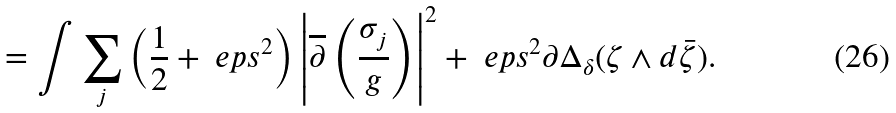<formula> <loc_0><loc_0><loc_500><loc_500>= \int \sum _ { j } \left ( \frac { 1 } { 2 } + { \ e p s } ^ { 2 } \right ) \left | \overline { \partial } \left ( \frac { \sigma _ { j } } { g } \right ) \right | ^ { 2 } + { \ e p s } ^ { 2 } \partial \Delta _ { \delta } ( \zeta \wedge d \bar { \zeta } ) .</formula> 